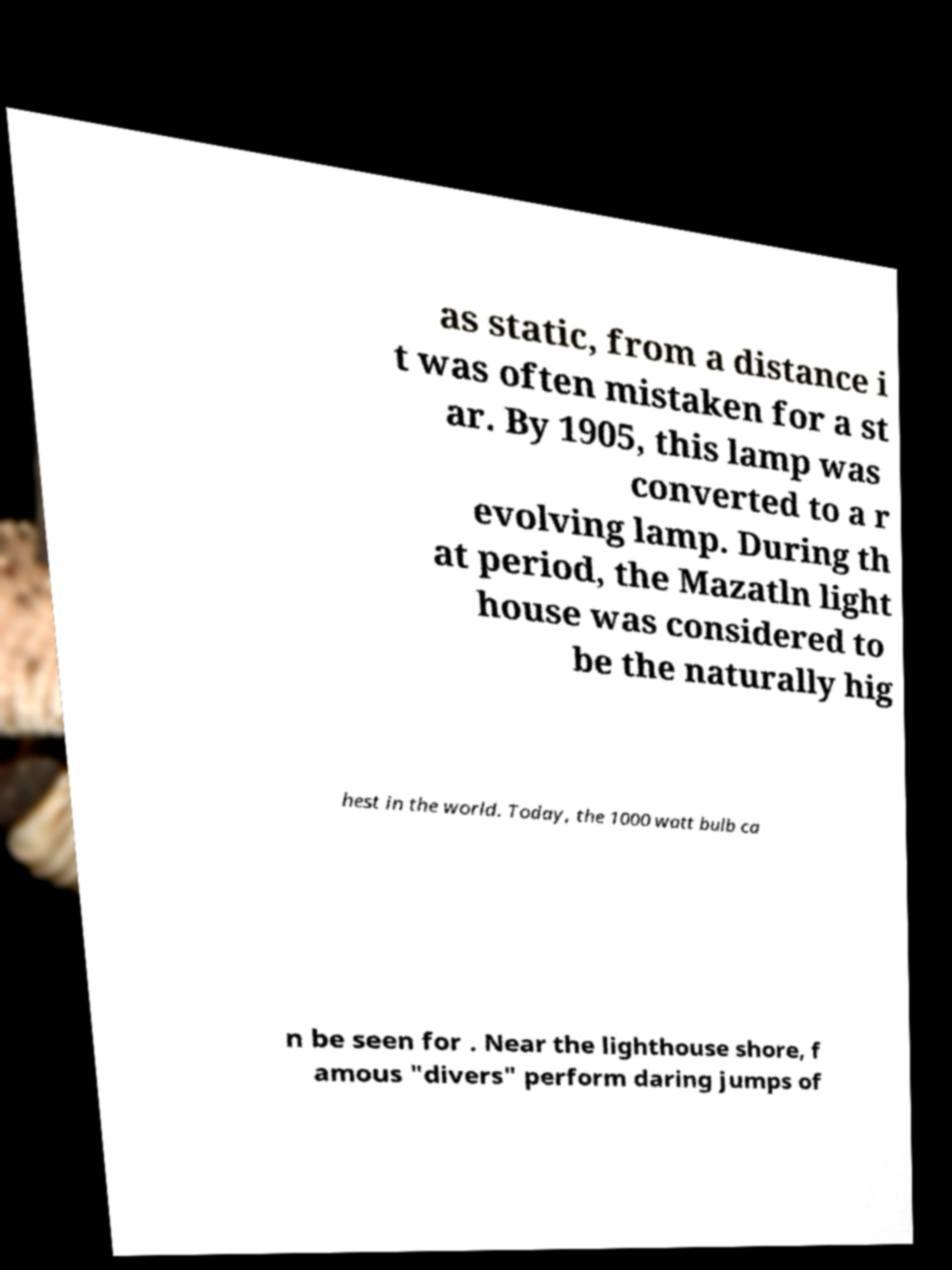Could you extract and type out the text from this image? as static, from a distance i t was often mistaken for a st ar. By 1905, this lamp was converted to a r evolving lamp. During th at period, the Mazatln light house was considered to be the naturally hig hest in the world. Today, the 1000 watt bulb ca n be seen for . Near the lighthouse shore, f amous "divers" perform daring jumps of 